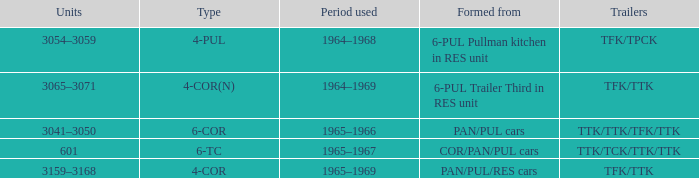Identify the trailers created from pan/pul/res vehicles. TFK/TTK. 